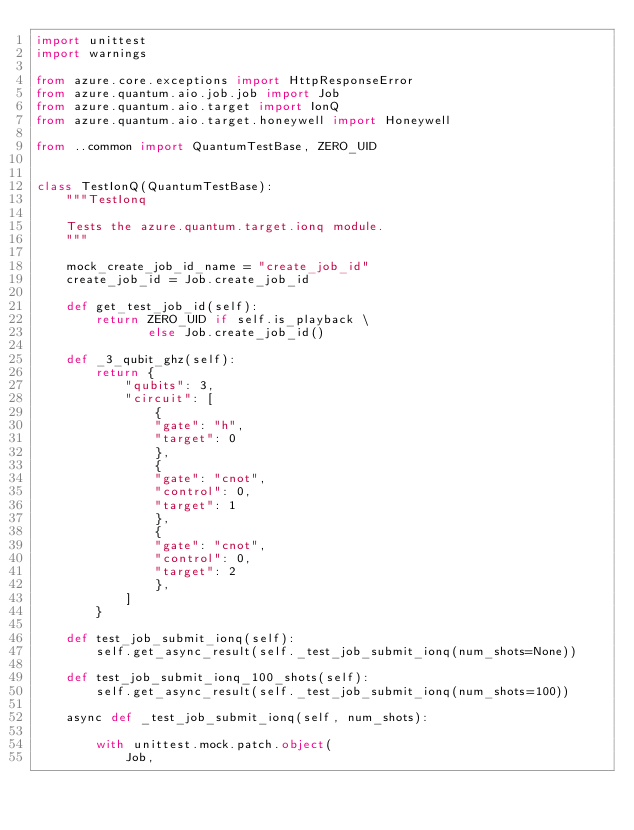<code> <loc_0><loc_0><loc_500><loc_500><_Python_>import unittest
import warnings

from azure.core.exceptions import HttpResponseError
from azure.quantum.aio.job.job import Job
from azure.quantum.aio.target import IonQ
from azure.quantum.aio.target.honeywell import Honeywell

from ..common import QuantumTestBase, ZERO_UID


class TestIonQ(QuantumTestBase):
    """TestIonq

    Tests the azure.quantum.target.ionq module.
    """

    mock_create_job_id_name = "create_job_id"
    create_job_id = Job.create_job_id

    def get_test_job_id(self):
        return ZERO_UID if self.is_playback \
               else Job.create_job_id()
    
    def _3_qubit_ghz(self):
        return {
            "qubits": 3,
            "circuit": [
                {
                "gate": "h",
                "target": 0
                },
                {
                "gate": "cnot",
                "control": 0,
                "target": 1
                },
                {
                "gate": "cnot",
                "control": 0,
                "target": 2
                },
            ]
        }

    def test_job_submit_ionq(self):
        self.get_async_result(self._test_job_submit_ionq(num_shots=None))

    def test_job_submit_ionq_100_shots(self):
        self.get_async_result(self._test_job_submit_ionq(num_shots=100))

    async def _test_job_submit_ionq(self, num_shots):

        with unittest.mock.patch.object(
            Job,</code> 